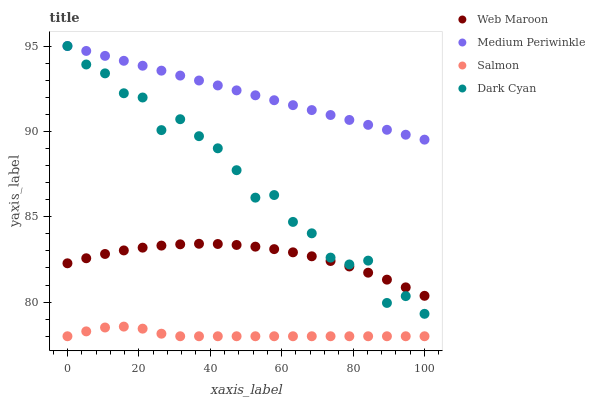Does Salmon have the minimum area under the curve?
Answer yes or no. Yes. Does Medium Periwinkle have the maximum area under the curve?
Answer yes or no. Yes. Does Web Maroon have the minimum area under the curve?
Answer yes or no. No. Does Web Maroon have the maximum area under the curve?
Answer yes or no. No. Is Medium Periwinkle the smoothest?
Answer yes or no. Yes. Is Dark Cyan the roughest?
Answer yes or no. Yes. Is Web Maroon the smoothest?
Answer yes or no. No. Is Web Maroon the roughest?
Answer yes or no. No. Does Salmon have the lowest value?
Answer yes or no. Yes. Does Web Maroon have the lowest value?
Answer yes or no. No. Does Medium Periwinkle have the highest value?
Answer yes or no. Yes. Does Web Maroon have the highest value?
Answer yes or no. No. Is Web Maroon less than Medium Periwinkle?
Answer yes or no. Yes. Is Medium Periwinkle greater than Web Maroon?
Answer yes or no. Yes. Does Web Maroon intersect Dark Cyan?
Answer yes or no. Yes. Is Web Maroon less than Dark Cyan?
Answer yes or no. No. Is Web Maroon greater than Dark Cyan?
Answer yes or no. No. Does Web Maroon intersect Medium Periwinkle?
Answer yes or no. No. 